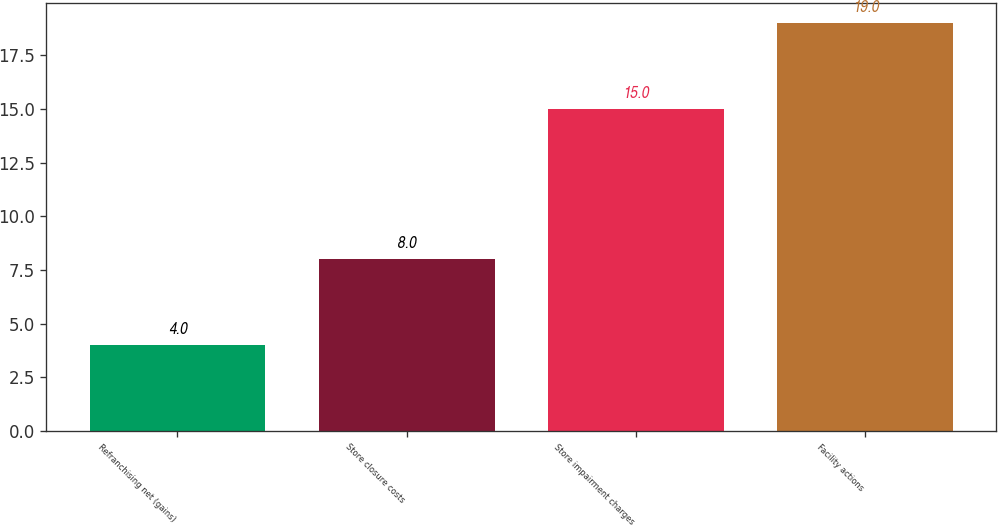<chart> <loc_0><loc_0><loc_500><loc_500><bar_chart><fcel>Refranchising net (gains)<fcel>Store closure costs<fcel>Store impairment charges<fcel>Facility actions<nl><fcel>4<fcel>8<fcel>15<fcel>19<nl></chart> 